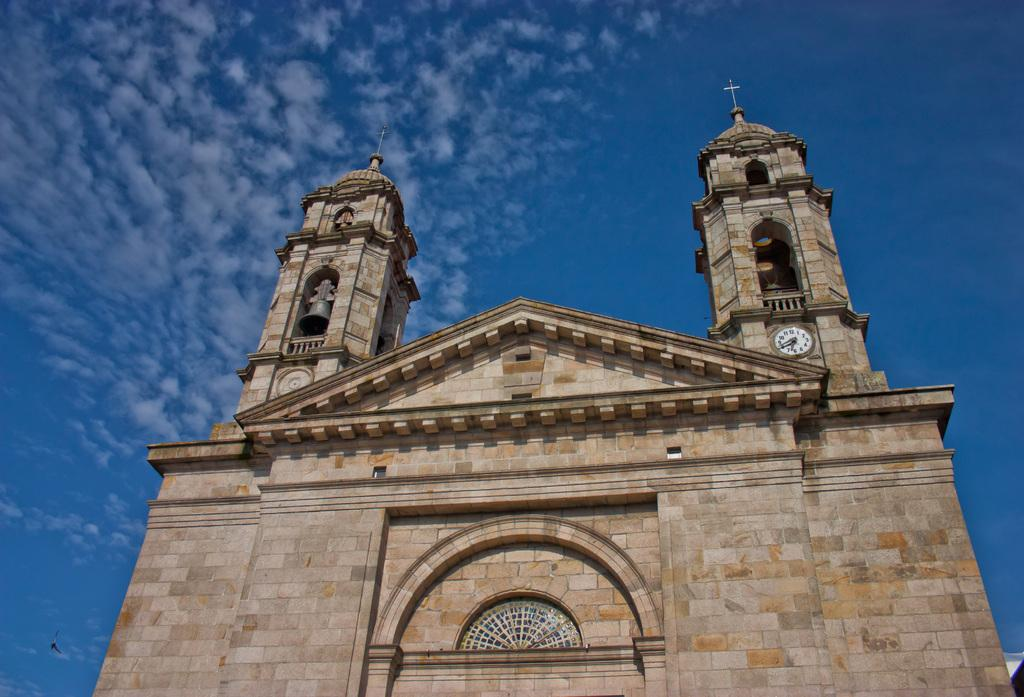What is the main structure visible in the foreground of the image? There is a fort in the foreground of the image. What color is the sky in the background of the image? The sky is blue in the background of the image. How many mice can be seen running around the fort in the image? There are no mice present in the image; it only features a fort and a blue sky. What type of stocking is hanging from the fort in the image? There is no stocking hanging from the fort in the image. 